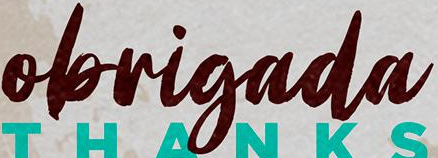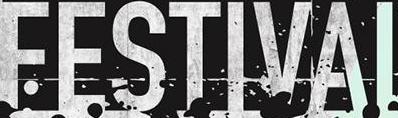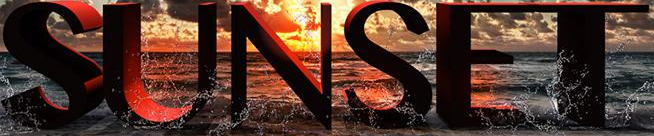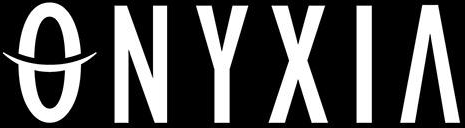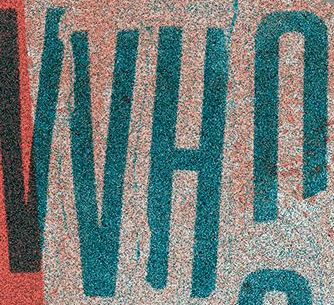Identify the words shown in these images in order, separated by a semicolon. obrigada; FESTIVAI; SUNSET; ONYXIA; VVHn 